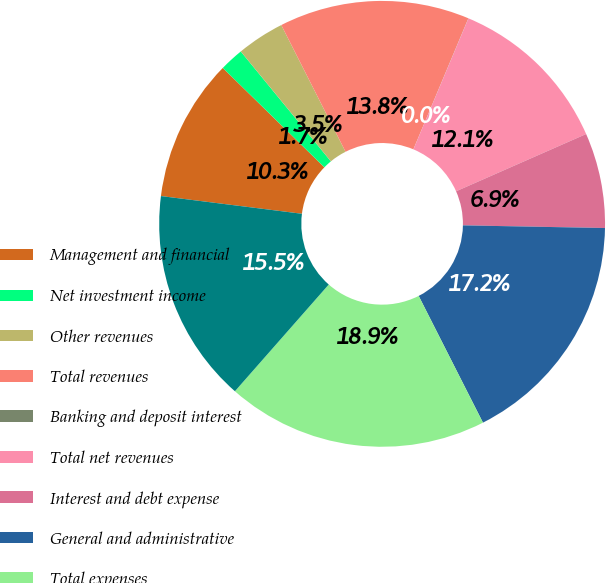<chart> <loc_0><loc_0><loc_500><loc_500><pie_chart><fcel>Management and financial<fcel>Net investment income<fcel>Other revenues<fcel>Total revenues<fcel>Banking and deposit interest<fcel>Total net revenues<fcel>Interest and debt expense<fcel>General and administrative<fcel>Total expenses<fcel>Pretax loss before equity in<nl><fcel>10.34%<fcel>1.74%<fcel>3.46%<fcel>13.79%<fcel>0.01%<fcel>12.07%<fcel>6.9%<fcel>17.23%<fcel>18.95%<fcel>15.51%<nl></chart> 